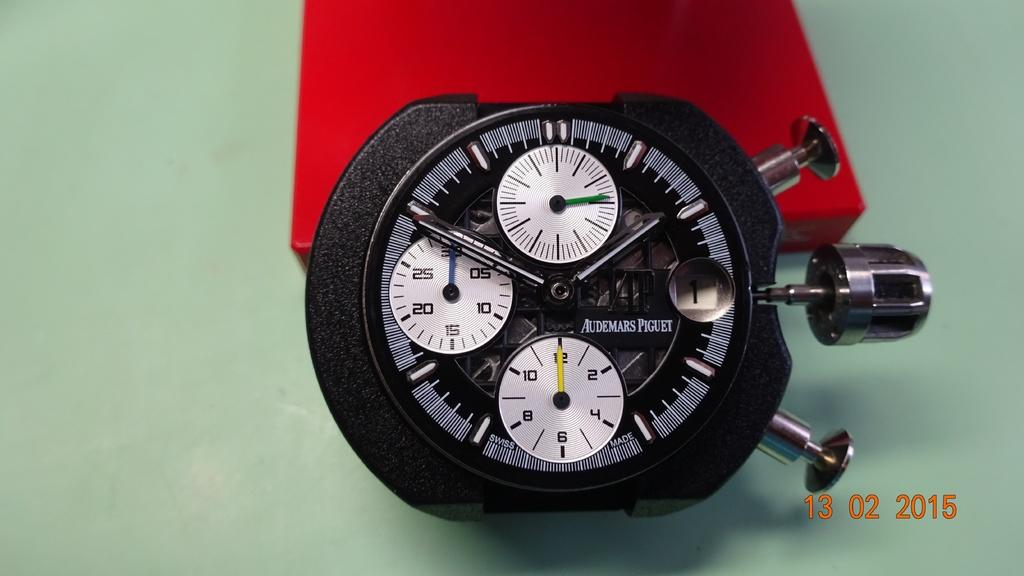What is the main subject of the image? There is a gadget in the image. Can you describe any other elements in the image? There is a red box in the background of the image. What type of patch is sewn onto the gadget in the image? There is no patch visible on the gadget in the image. 